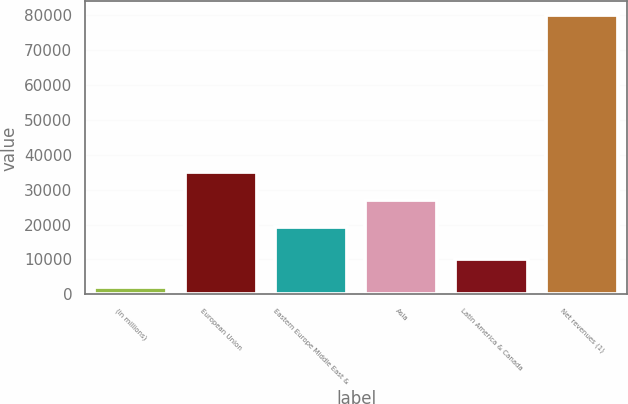Convert chart. <chart><loc_0><loc_0><loc_500><loc_500><bar_chart><fcel>(in millions)<fcel>European Union<fcel>Eastern Europe Middle East &<fcel>Asia<fcel>Latin America & Canada<fcel>Net revenues (1)<nl><fcel>2013<fcel>34945.2<fcel>19342<fcel>27143.6<fcel>10044<fcel>80029<nl></chart> 